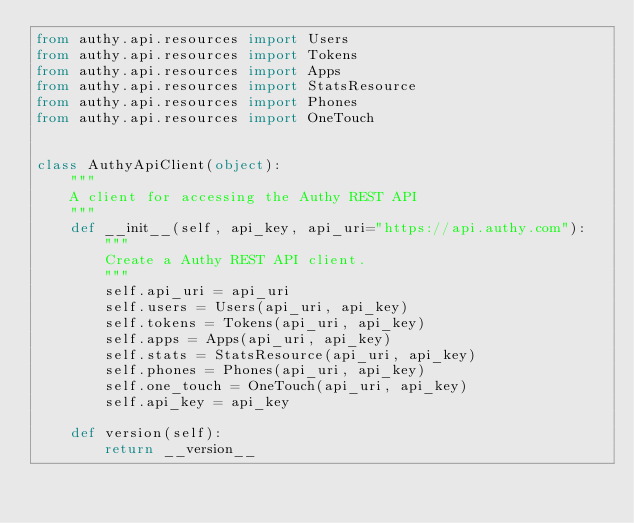<code> <loc_0><loc_0><loc_500><loc_500><_Python_>from authy.api.resources import Users
from authy.api.resources import Tokens
from authy.api.resources import Apps
from authy.api.resources import StatsResource
from authy.api.resources import Phones
from authy.api.resources import OneTouch


class AuthyApiClient(object):
    """
    A client for accessing the Authy REST API
    """
    def __init__(self, api_key, api_uri="https://api.authy.com"):
        """
        Create a Authy REST API client.
        """
        self.api_uri = api_uri
        self.users = Users(api_uri, api_key)
        self.tokens = Tokens(api_uri, api_key)
        self.apps = Apps(api_uri, api_key)
        self.stats = StatsResource(api_uri, api_key)
        self.phones = Phones(api_uri, api_key)
        self.one_touch = OneTouch(api_uri, api_key)
        self.api_key = api_key

    def version(self):
        return __version__

</code> 